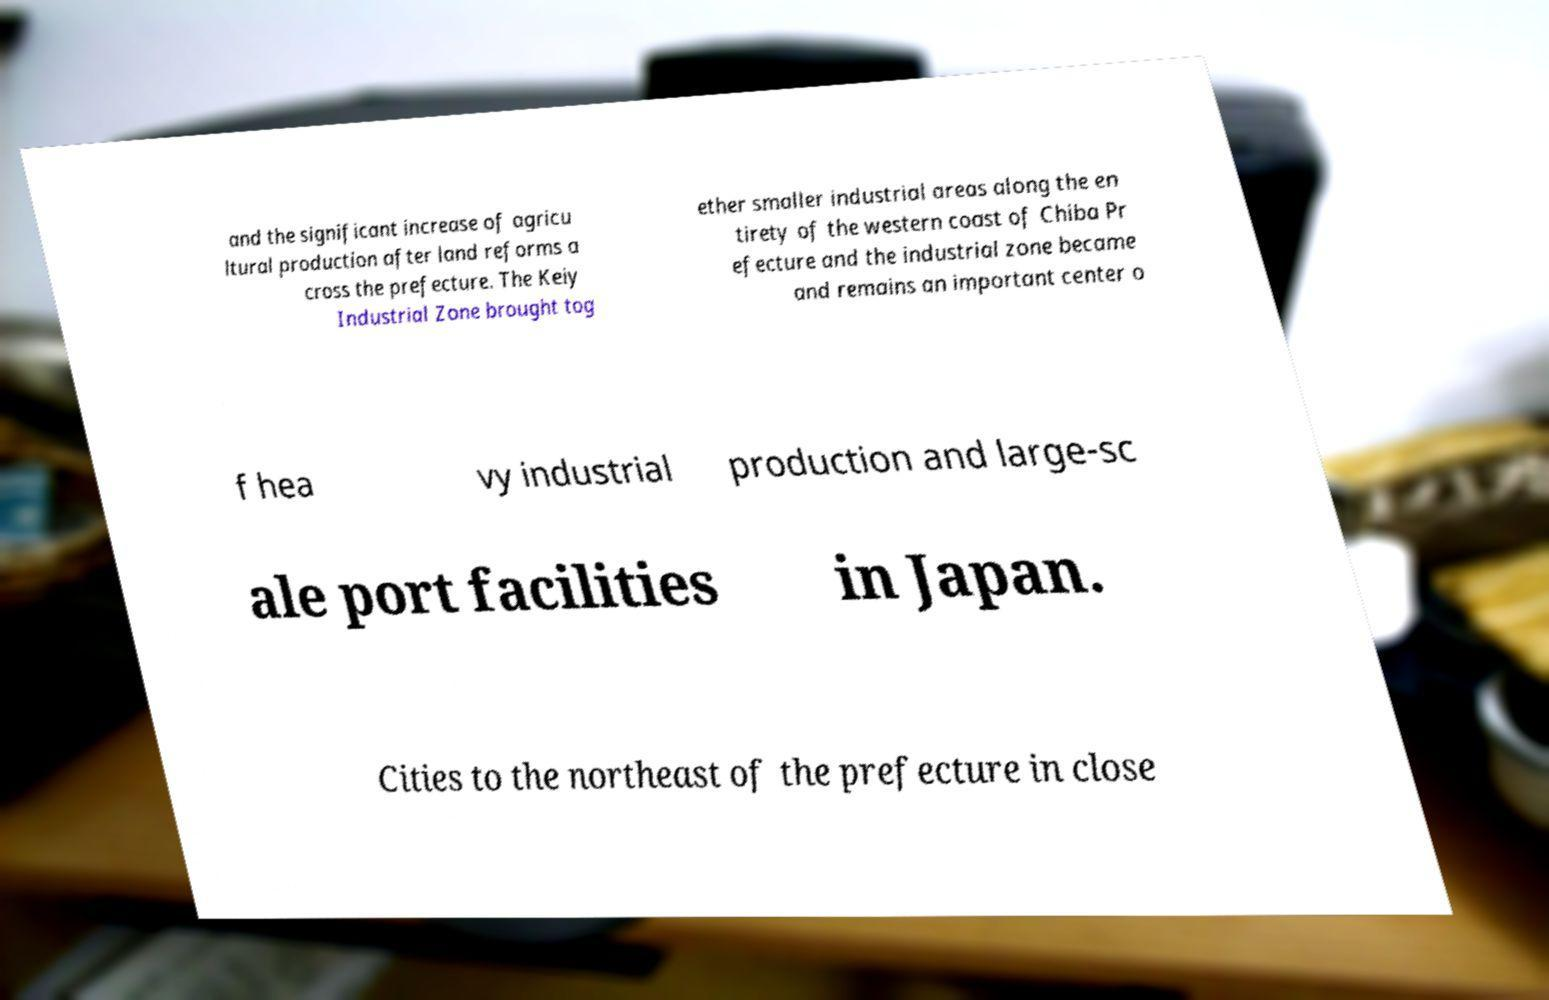Please identify and transcribe the text found in this image. and the significant increase of agricu ltural production after land reforms a cross the prefecture. The Keiy Industrial Zone brought tog ether smaller industrial areas along the en tirety of the western coast of Chiba Pr efecture and the industrial zone became and remains an important center o f hea vy industrial production and large-sc ale port facilities in Japan. Cities to the northeast of the prefecture in close 